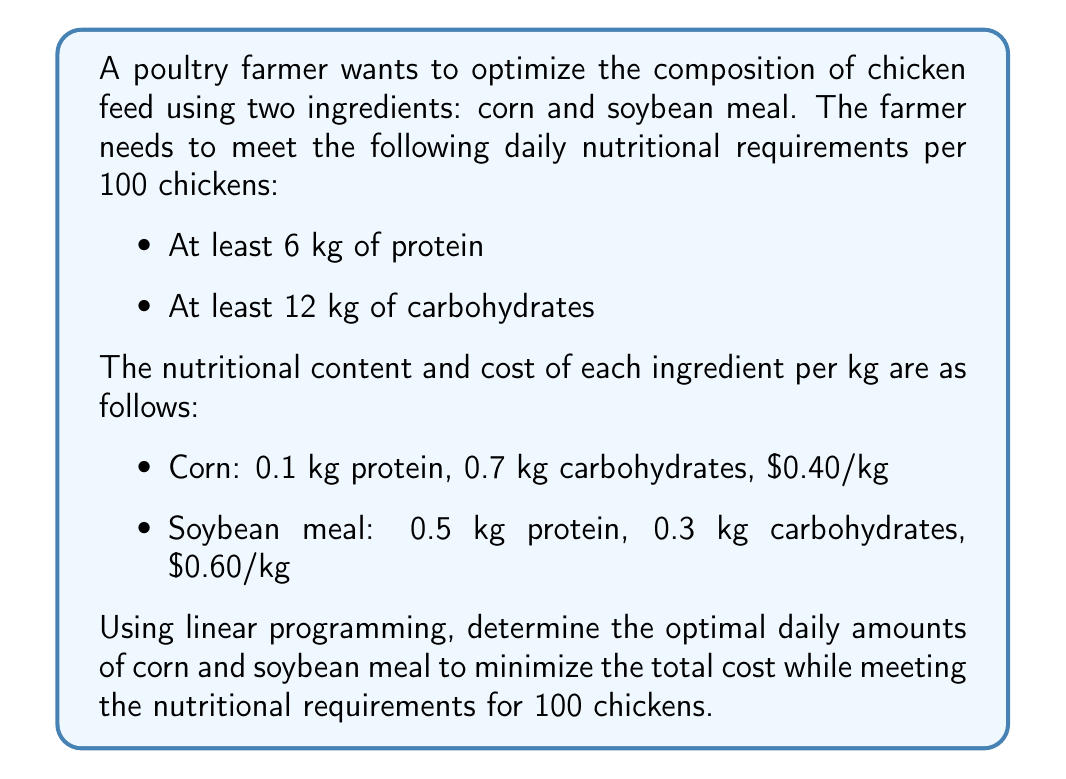Give your solution to this math problem. Let's solve this problem using linear programming:

1. Define variables:
   Let $x$ = kg of corn
   Let $y$ = kg of soybean meal

2. Objective function (minimize cost):
   $\text{Minimize } Z = 0.40x + 0.60y$

3. Constraints:
   Protein: $0.1x + 0.5y \geq 6$
   Carbohydrates: $0.7x + 0.3y \geq 12$
   Non-negativity: $x \geq 0, y \geq 0$

4. Graph the constraints:
   Protein: $y \geq 12 - 0.2x$
   Carbohydrates: $y \geq 40 - \frac{7}{3}x$

5. Find the corner points:
   Point A: $(0, 40)$ (intersection of y-axis and carbohydrate constraint)
   Point B: $(x, y)$ where the two constraints intersect:
   
   $$\begin{aligned}
   12 - 0.2x &= 40 - \frac{7}{3}x \\
   -28 &= -\frac{19}{3}x \\
   x &= \frac{84}{19} \approx 4.42
   \end{aligned}$$
   
   Substituting back: $y = 12 - 0.2(4.42) \approx 11.12$
   
   Point B: $(4.42, 11.12)$

6. Calculate the objective function value at each corner point:
   Point A: $Z = 0.40(0) + 0.60(40) = 24$
   Point B: $Z = 0.40(4.42) + 0.60(11.12) \approx 8.44$

7. The minimum cost occurs at Point B.
Answer: The optimal daily amounts are approximately 4.42 kg of corn and 11.12 kg of soybean meal, resulting in a minimum cost of $8.44 per day for 100 chickens. 